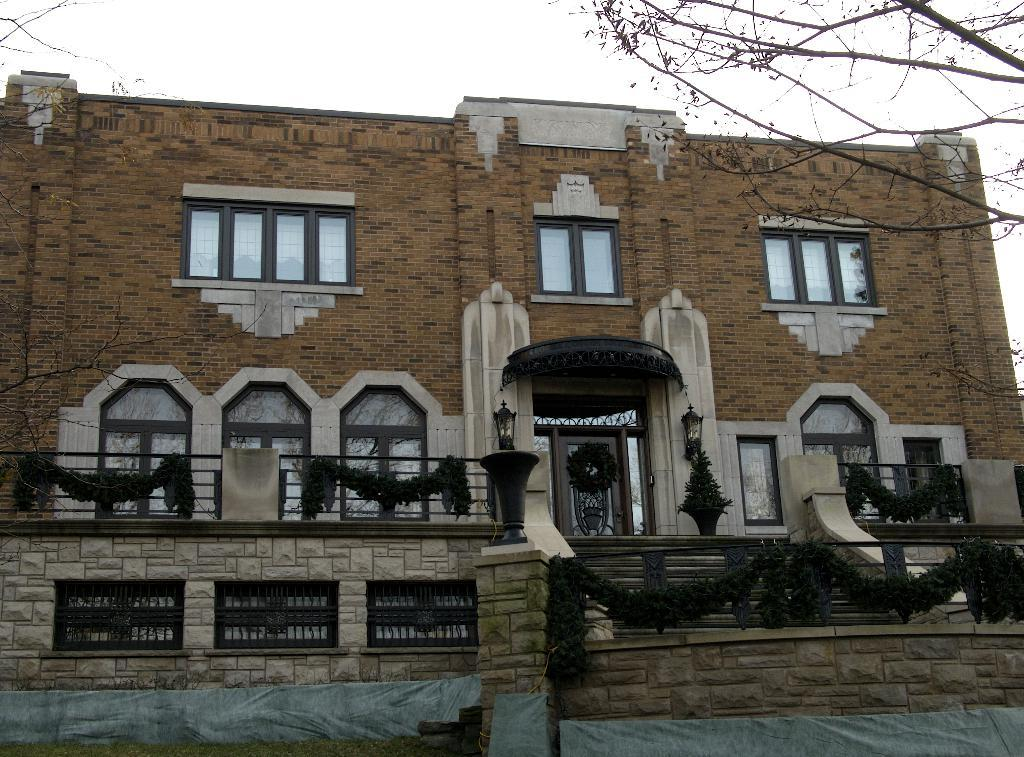What type of structure is present in the image? There is a building in the image. What feature can be seen on the building? The building has windows. What objects are present in the image besides the building? There are lamps and stairs visible in the image. What natural elements can be seen in the image? Tree branches are visible in the image. What is the color of the sky in the image? The sky is white in the image. What type of sweater is the tree wearing in the image? There is no sweater present in the image, as trees are not capable of wearing clothing. 